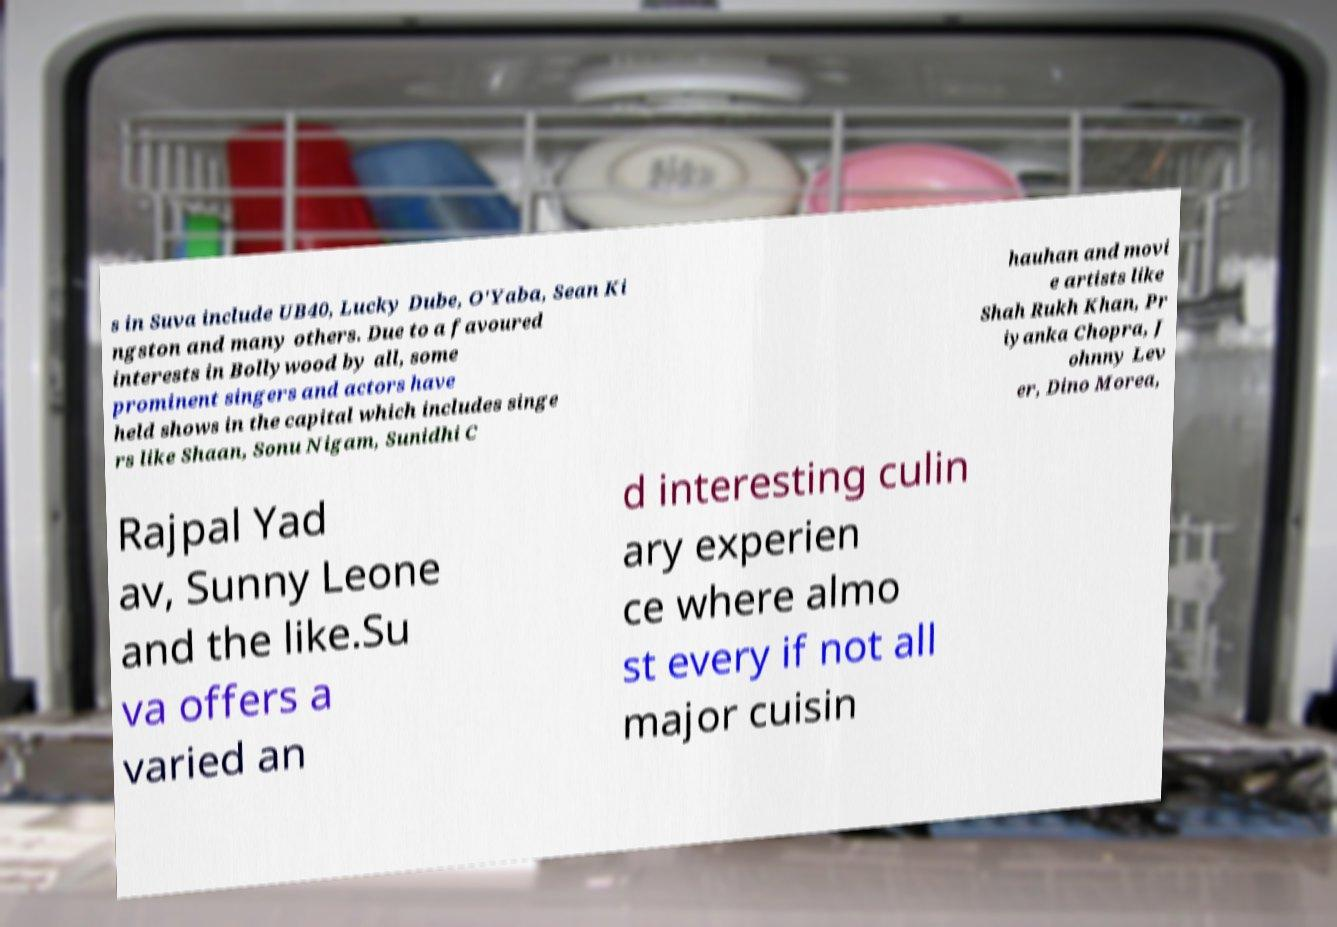Could you assist in decoding the text presented in this image and type it out clearly? s in Suva include UB40, Lucky Dube, O'Yaba, Sean Ki ngston and many others. Due to a favoured interests in Bollywood by all, some prominent singers and actors have held shows in the capital which includes singe rs like Shaan, Sonu Nigam, Sunidhi C hauhan and movi e artists like Shah Rukh Khan, Pr iyanka Chopra, J ohnny Lev er, Dino Morea, Rajpal Yad av, Sunny Leone and the like.Su va offers a varied an d interesting culin ary experien ce where almo st every if not all major cuisin 